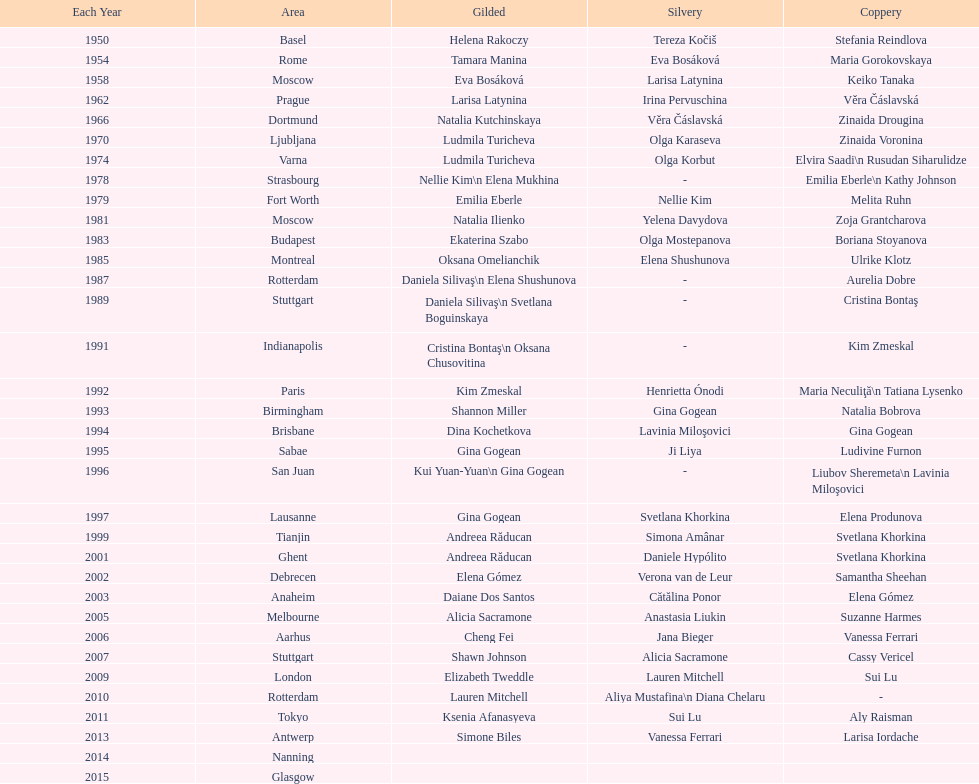Where did the world artistic gymnastics take place before san juan? Sabae. 